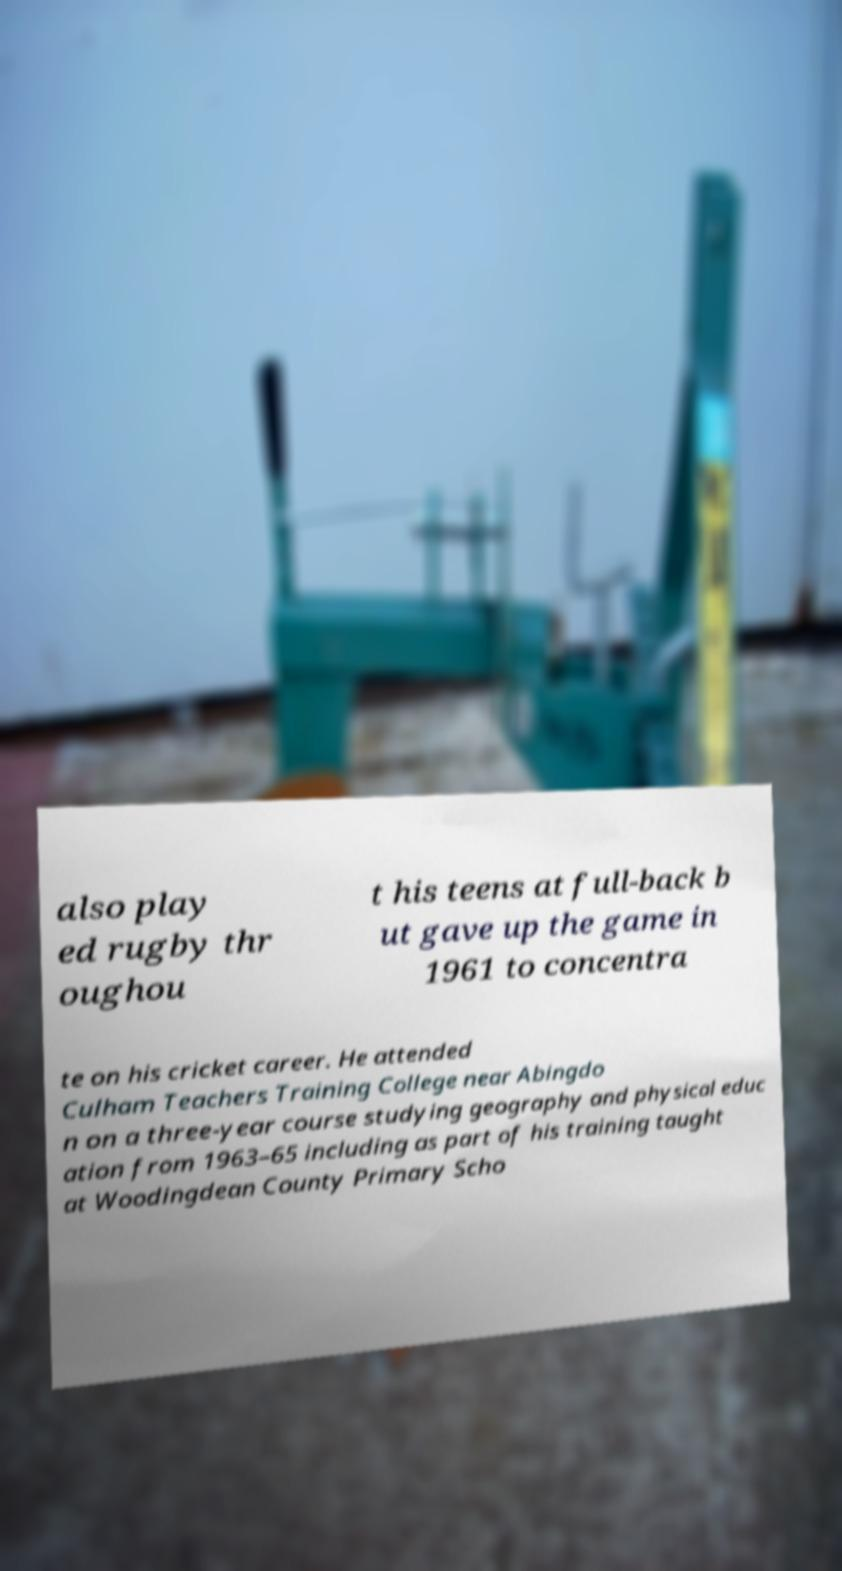What messages or text are displayed in this image? I need them in a readable, typed format. also play ed rugby thr oughou t his teens at full-back b ut gave up the game in 1961 to concentra te on his cricket career. He attended Culham Teachers Training College near Abingdo n on a three-year course studying geography and physical educ ation from 1963–65 including as part of his training taught at Woodingdean County Primary Scho 